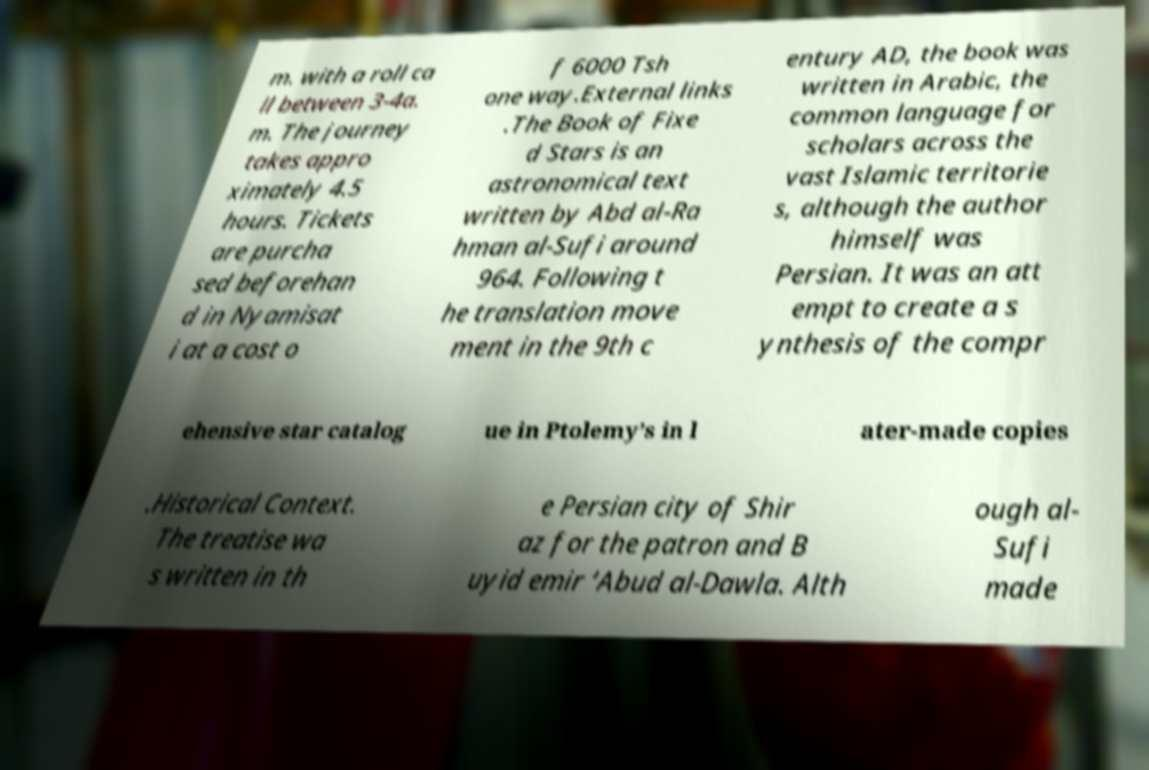What messages or text are displayed in this image? I need them in a readable, typed format. m. with a roll ca ll between 3-4a. m. The journey takes appro ximately 4.5 hours. Tickets are purcha sed beforehan d in Nyamisat i at a cost o f 6000 Tsh one way.External links .The Book of Fixe d Stars is an astronomical text written by Abd al-Ra hman al-Sufi around 964. Following t he translation move ment in the 9th c entury AD, the book was written in Arabic, the common language for scholars across the vast Islamic territorie s, although the author himself was Persian. It was an att empt to create a s ynthesis of the compr ehensive star catalog ue in Ptolemy’s in l ater-made copies .Historical Context. The treatise wa s written in th e Persian city of Shir az for the patron and B uyid emir ‘Abud al-Dawla. Alth ough al- Sufi made 